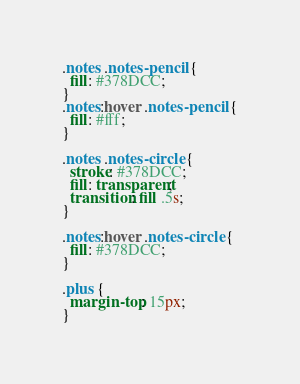Convert code to text. <code><loc_0><loc_0><loc_500><loc_500><_CSS_>.notes .notes-pencil {
  fill: #378DCC;
}
.notes:hover .notes-pencil {
  fill: #fff;
}

.notes .notes-circle {
  stroke: #378DCC;
  fill: transparent;
  transition: fill .5s;
}

.notes:hover .notes-circle {
  fill: #378DCC;
}

.plus {
  margin-top: 15px;
}
</code> 